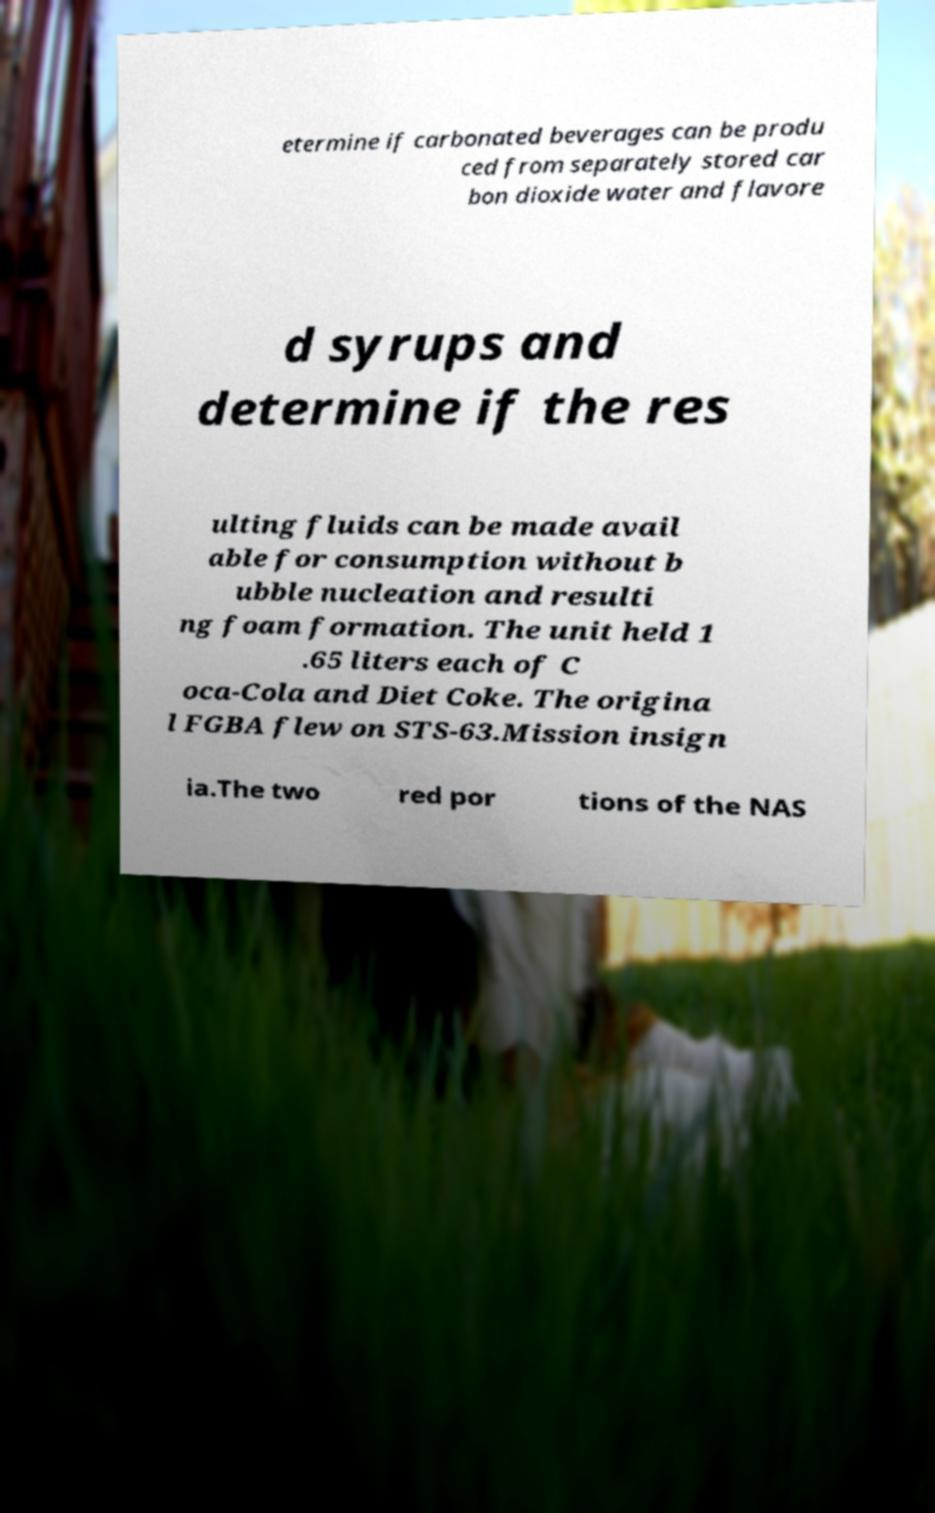Could you assist in decoding the text presented in this image and type it out clearly? etermine if carbonated beverages can be produ ced from separately stored car bon dioxide water and flavore d syrups and determine if the res ulting fluids can be made avail able for consumption without b ubble nucleation and resulti ng foam formation. The unit held 1 .65 liters each of C oca-Cola and Diet Coke. The origina l FGBA flew on STS-63.Mission insign ia.The two red por tions of the NAS 